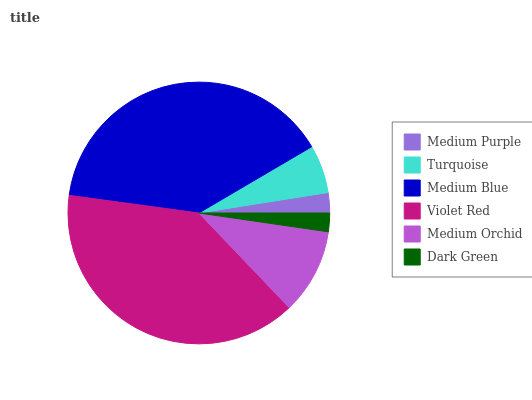Is Dark Green the minimum?
Answer yes or no. Yes. Is Medium Blue the maximum?
Answer yes or no. Yes. Is Turquoise the minimum?
Answer yes or no. No. Is Turquoise the maximum?
Answer yes or no. No. Is Turquoise greater than Medium Purple?
Answer yes or no. Yes. Is Medium Purple less than Turquoise?
Answer yes or no. Yes. Is Medium Purple greater than Turquoise?
Answer yes or no. No. Is Turquoise less than Medium Purple?
Answer yes or no. No. Is Medium Orchid the high median?
Answer yes or no. Yes. Is Turquoise the low median?
Answer yes or no. Yes. Is Violet Red the high median?
Answer yes or no. No. Is Dark Green the low median?
Answer yes or no. No. 